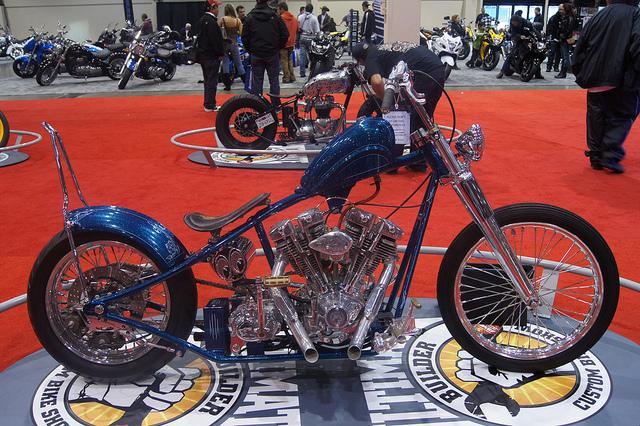What color is the bike that's the closest?
Write a very short answer. Blue. Where are there two orange cones?
Keep it brief. Nowhere. Are the motorcycles on display?
Give a very brief answer. Yes. What is the bike for?
Quick response, please. Riding. What color is the bike?
Concise answer only. Blue. 